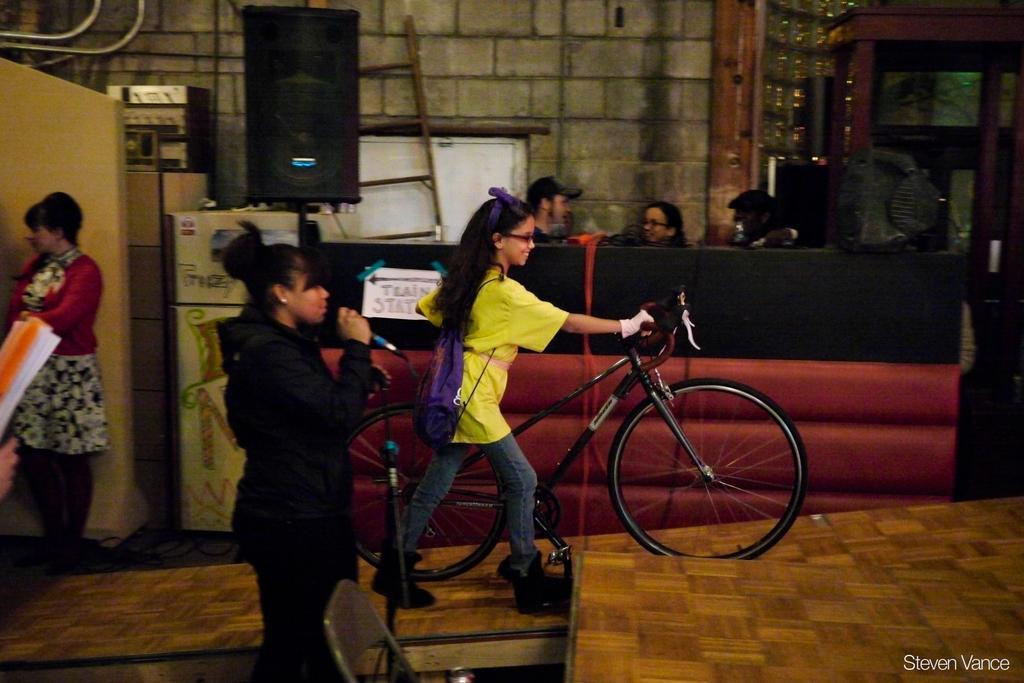How would you summarize this image in a sentence or two? A room which is made of big bricks wall and there are six people in the room in which a women is holding a mike and other three people are sitting behind the desk and the other girl holding a bicycle and also there is a speaker. 